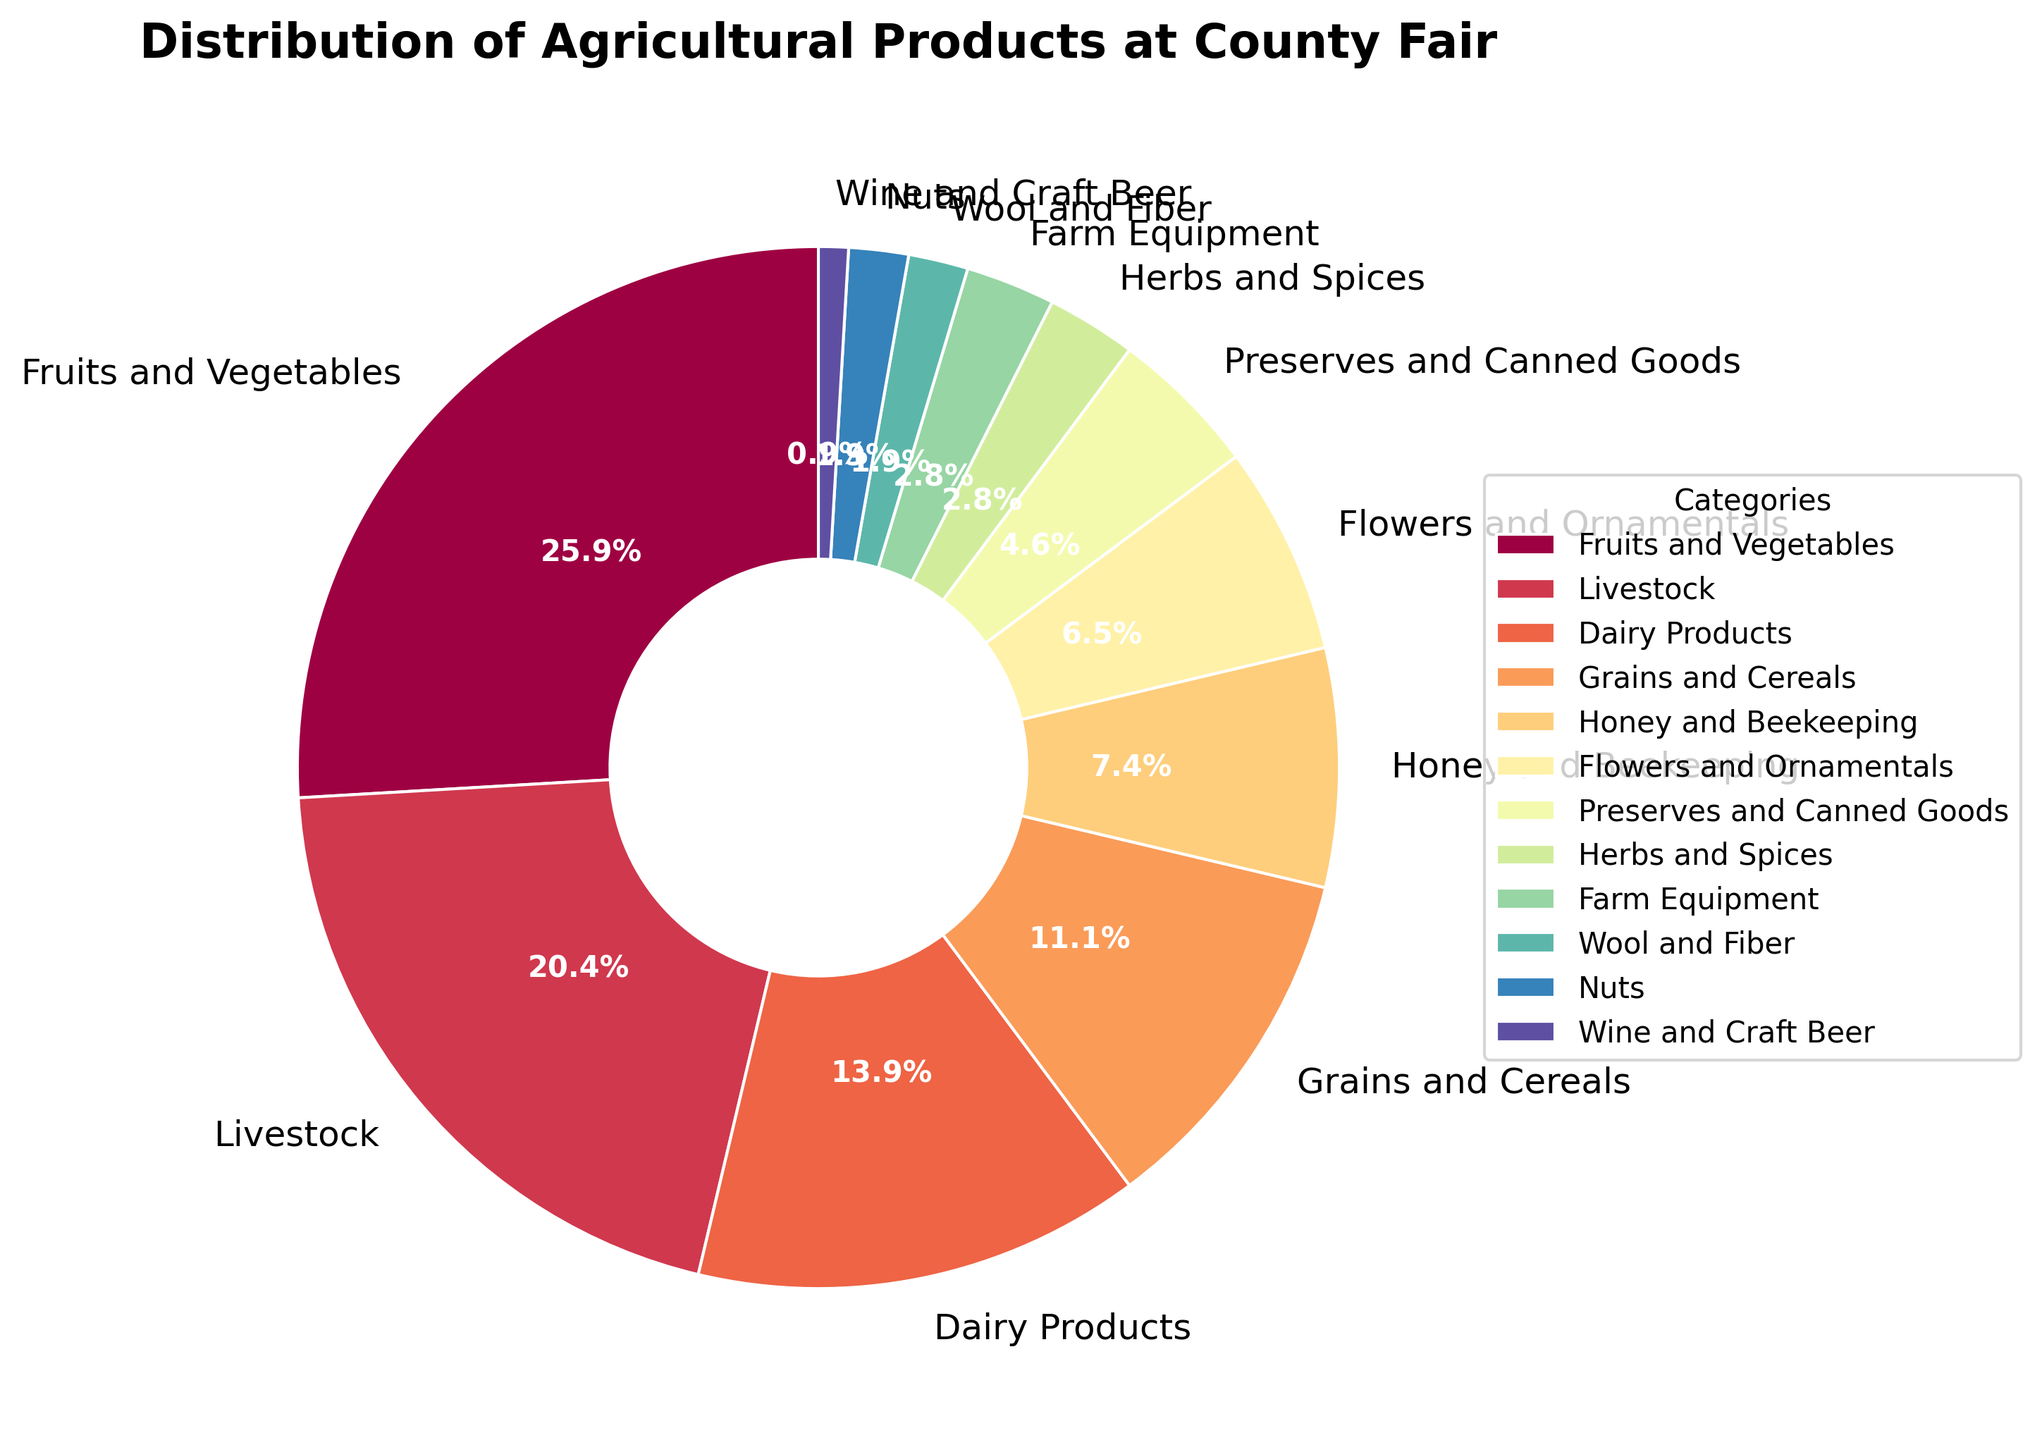Which category has the highest representation in the pie chart? The slice labeled "Fruits and Vegetables" appears to be the largest segment of the pie chart, indicating it has the highest representation.
Answer: Fruits and Vegetables Which category has the lowest percentage? The pie chart shows a very small slice labeled "Wine and Craft Beer" compared to the other categories, indicating it has the lowest percentage.
Answer: Wine and Craft Beer Are there more categories with percentages above or below 10%? By examining the pie chart, we see that categories above 10% are Fruits and Vegetables, Livestock, Dairy Products, and Grains and Cereals (4 categories). The remaining categories are below 10% (8 categories). Thus, there are more categories below 10%.
Answer: Below What is the combined percentage of Dairy Products and Grains and Cereals? The pie chart shows Dairy Products at 15% and Grains and Cereals at 12%. Adding these percentages: 15% + 12% = 27%.
Answer: 27% Compare the representation of Livestock to Dairy Products. Which category is larger? The pie chart shows Livestock at 22% and Dairy Products at 15%. 22% is greater than 15%, so Livestock has a larger representation.
Answer: Livestock How much larger is the percentage of Fruits and Vegetables compared to Flowers and Ornamentals? The percentage of Fruits and Vegetables is 28% and Flowers and Ornamentals is 7%. The difference is 28% - 7% = 21%.
Answer: 21% Which categories occupy more than one-fifth of the pie chart? One-fifth of the pie chart is equivalent to 20%. By examining the chart, we see that only Fruits and Vegetables (28%) and Livestock (22%) are above this threshold.
Answer: Fruits and Vegetables, Livestock Is the percentage of Nuts and Wool and Fiber combined smaller than Honey and Beekeeping? By how much? Nuts and Wool and Fiber are 2% each, so combined they make 2% + 2% = 4%. Honey and Beekeeping is 8%. The difference is 8% - 4% = 4%.
Answer: Yes, by 4% Which two categories have equal representation in the pie chart? The chart shows Herbs and Spices and Farm Equipment both with 3%.
Answer: Herbs and Spices, Farm Equipment What is the total percentage represented by non-food categories? Non-food categories are Flowers and Ornamentals (7%), Farm Equipment (3%), Wool and Fiber (2%), and Wine and Craft Beer (1%). Summing them: 7% + 3% + 2% + 1% = 13%.
Answer: 13% 